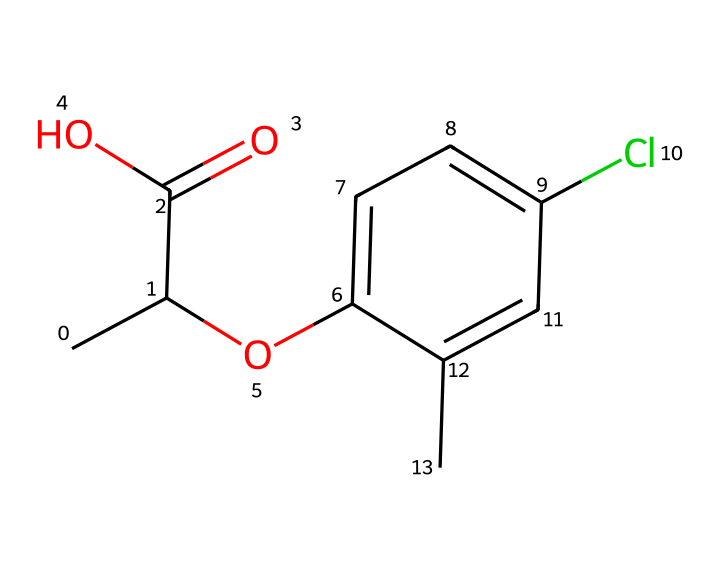How many carbon atoms are in mecoprop? Analyzing the SMILES representation, each "C" indicates a carbon atom. Counting all carbon atoms in the structure gives a total of 9 carbon atoms.
Answer: 9 What functional groups are present in mecoprop? The chemical structure shows a carboxylic acid group (C(=O)O) and an ether group (O). These distinguishable groups indicate the chemical's functional properties.
Answer: carboxylic acid, ether What is the molecular weight of mecoprop? To calculate the molecular weight, we can sum the atomic weights of all atoms in the chemical structure. The total molecular weight of mecoprop is approximately 194.6 g/mol.
Answer: 194.6 How many chlorine atoms are present in mecoprop? The SMILES representation contains one "Cl," indicating that there is a single chlorine atom in the structure.
Answer: 1 What type of herbicide is mecoprop classified as? Mecoprop is identified as a selective herbicide, as indicated by its structure which targets specific plant species while minimizing harm to others.
Answer: selective herbicide What is the primary use of mecoprop in agriculture? The presence of specific chemical features suggests that mecoprop is used mainly to manage broadleaf weeds in turf and ornamental plants, indicative of its application in sports fields and golf courses.
Answer: manage broadleaf weeds 